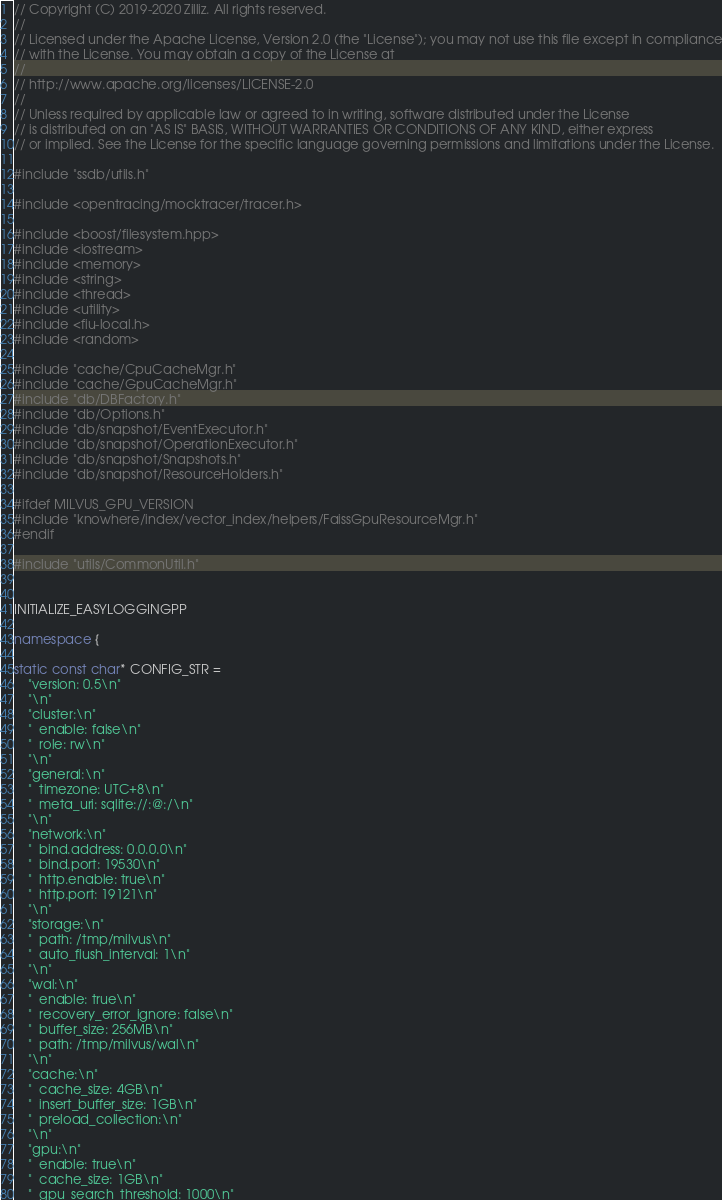Convert code to text. <code><loc_0><loc_0><loc_500><loc_500><_C++_>// Copyright (C) 2019-2020 Zilliz. All rights reserved.
//
// Licensed under the Apache License, Version 2.0 (the "License"); you may not use this file except in compliance
// with the License. You may obtain a copy of the License at
//
// http://www.apache.org/licenses/LICENSE-2.0
//
// Unless required by applicable law or agreed to in writing, software distributed under the License
// is distributed on an "AS IS" BASIS, WITHOUT WARRANTIES OR CONDITIONS OF ANY KIND, either express
// or implied. See the License for the specific language governing permissions and limitations under the License.

#include "ssdb/utils.h"

#include <opentracing/mocktracer/tracer.h>

#include <boost/filesystem.hpp>
#include <iostream>
#include <memory>
#include <string>
#include <thread>
#include <utility>
#include <fiu-local.h>
#include <random>

#include "cache/CpuCacheMgr.h"
#include "cache/GpuCacheMgr.h"
#include "db/DBFactory.h"
#include "db/Options.h"
#include "db/snapshot/EventExecutor.h"
#include "db/snapshot/OperationExecutor.h"
#include "db/snapshot/Snapshots.h"
#include "db/snapshot/ResourceHolders.h"

#ifdef MILVUS_GPU_VERSION
#include "knowhere/index/vector_index/helpers/FaissGpuResourceMgr.h"
#endif

#include "utils/CommonUtil.h"


INITIALIZE_EASYLOGGINGPP

namespace {

static const char* CONFIG_STR =
    "version: 0.5\n"
    "\n"
    "cluster:\n"
    "  enable: false\n"
    "  role: rw\n"
    "\n"
    "general:\n"
    "  timezone: UTC+8\n"
    "  meta_uri: sqlite://:@:/\n"
    "\n"
    "network:\n"
    "  bind.address: 0.0.0.0\n"
    "  bind.port: 19530\n"
    "  http.enable: true\n"
    "  http.port: 19121\n"
    "\n"
    "storage:\n"
    "  path: /tmp/milvus\n"
    "  auto_flush_interval: 1\n"
    "\n"
    "wal:\n"
    "  enable: true\n"
    "  recovery_error_ignore: false\n"
    "  buffer_size: 256MB\n"
    "  path: /tmp/milvus/wal\n"
    "\n"
    "cache:\n"
    "  cache_size: 4GB\n"
    "  insert_buffer_size: 1GB\n"
    "  preload_collection:\n"
    "\n"
    "gpu:\n"
    "  enable: true\n"
    "  cache_size: 1GB\n"
    "  gpu_search_threshold: 1000\n"</code> 